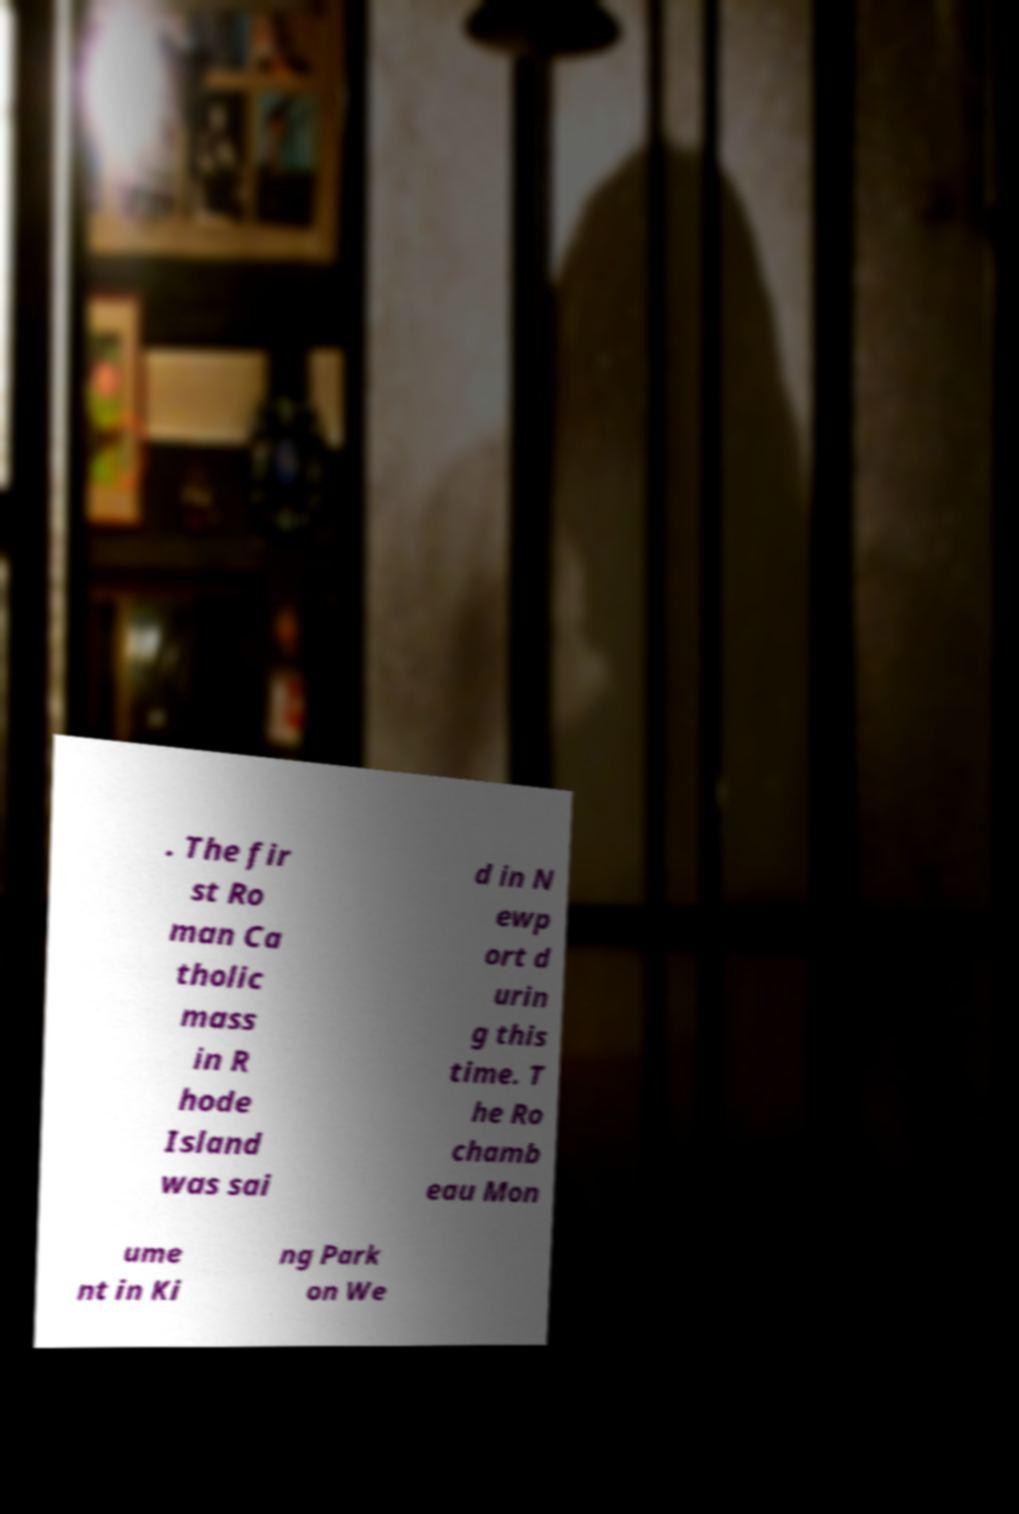For documentation purposes, I need the text within this image transcribed. Could you provide that? . The fir st Ro man Ca tholic mass in R hode Island was sai d in N ewp ort d urin g this time. T he Ro chamb eau Mon ume nt in Ki ng Park on We 